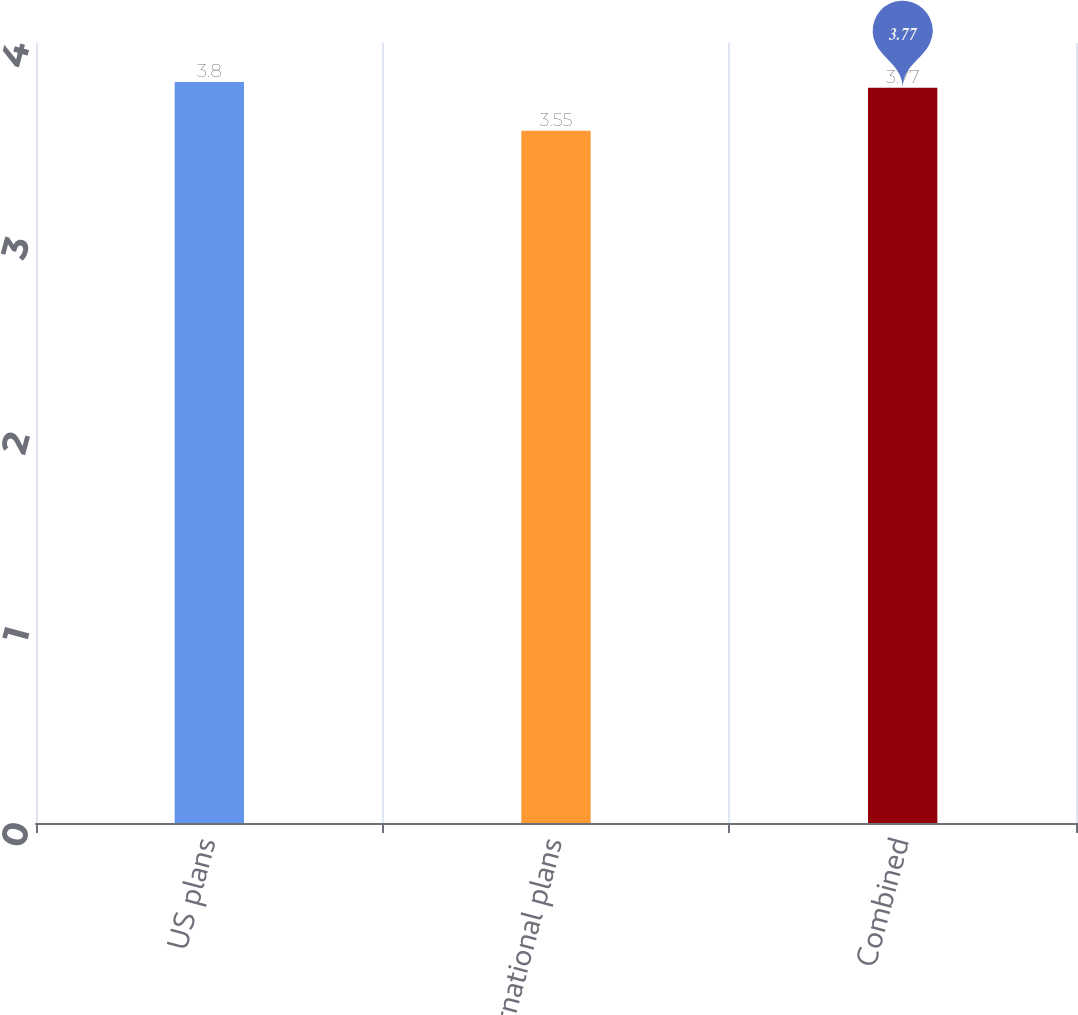<chart> <loc_0><loc_0><loc_500><loc_500><bar_chart><fcel>US plans<fcel>International plans<fcel>Combined<nl><fcel>3.8<fcel>3.55<fcel>3.77<nl></chart> 